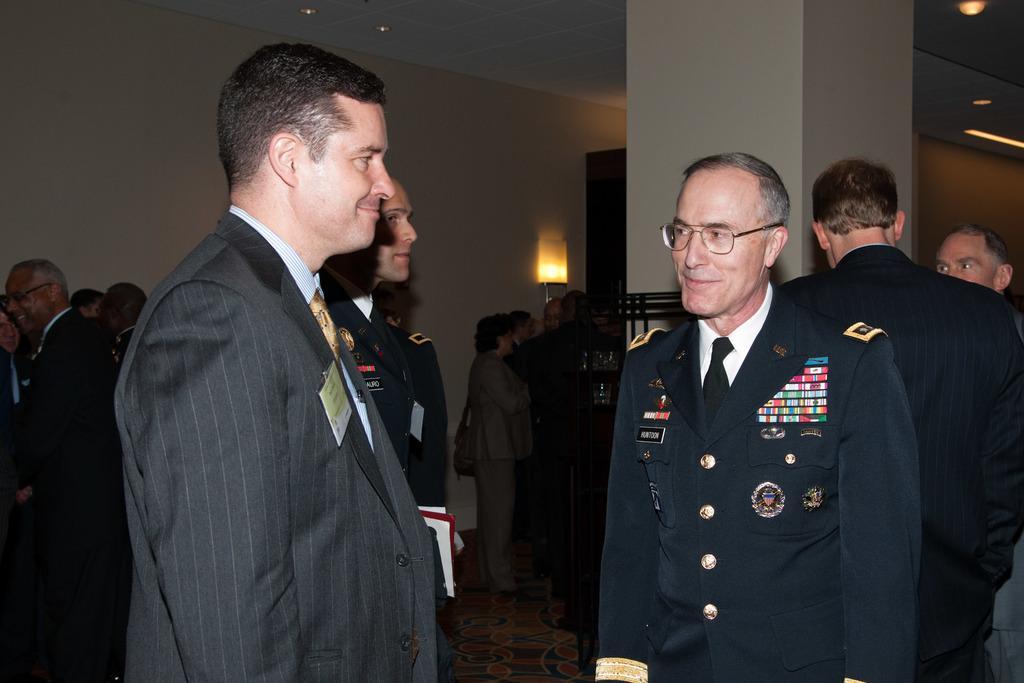How would you summarize this image in a sentence or two? In this image, there are a few people. We can see the ground and a pillar. We can also see the wall with an object. We can see some black colored objects. We can also see the roof with some lights. 